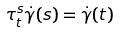Convert formula to latex. <formula><loc_0><loc_0><loc_500><loc_500>\tau _ { t } ^ { s } \dot { \gamma } ( s ) = \dot { \gamma } ( t )</formula> 